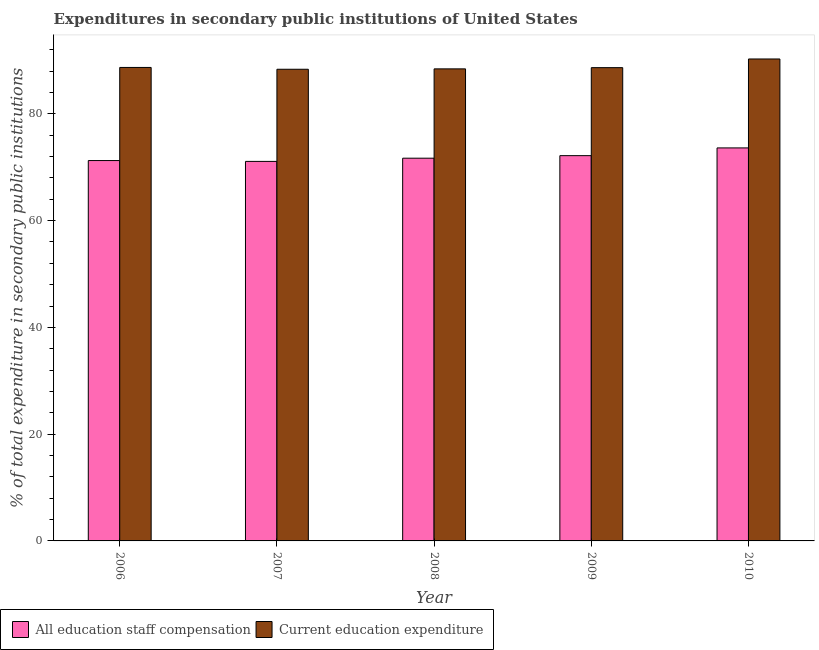How many different coloured bars are there?
Offer a terse response. 2. How many groups of bars are there?
Your answer should be compact. 5. Are the number of bars per tick equal to the number of legend labels?
Keep it short and to the point. Yes. How many bars are there on the 4th tick from the right?
Your answer should be very brief. 2. What is the label of the 4th group of bars from the left?
Give a very brief answer. 2009. What is the expenditure in education in 2009?
Keep it short and to the point. 88.65. Across all years, what is the maximum expenditure in staff compensation?
Make the answer very short. 73.62. Across all years, what is the minimum expenditure in education?
Your answer should be compact. 88.35. What is the total expenditure in staff compensation in the graph?
Offer a terse response. 359.8. What is the difference between the expenditure in education in 2008 and that in 2010?
Your answer should be compact. -1.85. What is the difference between the expenditure in education in 2010 and the expenditure in staff compensation in 2007?
Provide a succinct answer. 1.93. What is the average expenditure in education per year?
Ensure brevity in your answer.  88.88. What is the ratio of the expenditure in staff compensation in 2006 to that in 2010?
Your answer should be compact. 0.97. What is the difference between the highest and the second highest expenditure in staff compensation?
Offer a very short reply. 1.45. What is the difference between the highest and the lowest expenditure in education?
Provide a short and direct response. 1.93. Is the sum of the expenditure in education in 2007 and 2009 greater than the maximum expenditure in staff compensation across all years?
Your answer should be compact. Yes. What does the 2nd bar from the left in 2006 represents?
Offer a terse response. Current education expenditure. What does the 2nd bar from the right in 2007 represents?
Offer a very short reply. All education staff compensation. Does the graph contain any zero values?
Your answer should be very brief. No. Does the graph contain grids?
Your answer should be compact. No. Where does the legend appear in the graph?
Your answer should be very brief. Bottom left. What is the title of the graph?
Your response must be concise. Expenditures in secondary public institutions of United States. What is the label or title of the X-axis?
Your answer should be compact. Year. What is the label or title of the Y-axis?
Provide a succinct answer. % of total expenditure in secondary public institutions. What is the % of total expenditure in secondary public institutions of All education staff compensation in 2006?
Offer a very short reply. 71.25. What is the % of total expenditure in secondary public institutions of Current education expenditure in 2006?
Your answer should be very brief. 88.69. What is the % of total expenditure in secondary public institutions of All education staff compensation in 2007?
Your response must be concise. 71.09. What is the % of total expenditure in secondary public institutions in Current education expenditure in 2007?
Make the answer very short. 88.35. What is the % of total expenditure in secondary public institutions in All education staff compensation in 2008?
Provide a succinct answer. 71.69. What is the % of total expenditure in secondary public institutions in Current education expenditure in 2008?
Your answer should be compact. 88.42. What is the % of total expenditure in secondary public institutions of All education staff compensation in 2009?
Provide a succinct answer. 72.17. What is the % of total expenditure in secondary public institutions of Current education expenditure in 2009?
Your response must be concise. 88.65. What is the % of total expenditure in secondary public institutions in All education staff compensation in 2010?
Provide a short and direct response. 73.62. What is the % of total expenditure in secondary public institutions of Current education expenditure in 2010?
Give a very brief answer. 90.27. Across all years, what is the maximum % of total expenditure in secondary public institutions in All education staff compensation?
Provide a short and direct response. 73.62. Across all years, what is the maximum % of total expenditure in secondary public institutions in Current education expenditure?
Provide a short and direct response. 90.27. Across all years, what is the minimum % of total expenditure in secondary public institutions of All education staff compensation?
Keep it short and to the point. 71.09. Across all years, what is the minimum % of total expenditure in secondary public institutions in Current education expenditure?
Make the answer very short. 88.35. What is the total % of total expenditure in secondary public institutions of All education staff compensation in the graph?
Your answer should be compact. 359.8. What is the total % of total expenditure in secondary public institutions in Current education expenditure in the graph?
Keep it short and to the point. 444.38. What is the difference between the % of total expenditure in secondary public institutions of All education staff compensation in 2006 and that in 2007?
Make the answer very short. 0.16. What is the difference between the % of total expenditure in secondary public institutions in Current education expenditure in 2006 and that in 2007?
Your response must be concise. 0.34. What is the difference between the % of total expenditure in secondary public institutions of All education staff compensation in 2006 and that in 2008?
Ensure brevity in your answer.  -0.44. What is the difference between the % of total expenditure in secondary public institutions of Current education expenditure in 2006 and that in 2008?
Your answer should be very brief. 0.27. What is the difference between the % of total expenditure in secondary public institutions of All education staff compensation in 2006 and that in 2009?
Make the answer very short. -0.92. What is the difference between the % of total expenditure in secondary public institutions of Current education expenditure in 2006 and that in 2009?
Your answer should be very brief. 0.04. What is the difference between the % of total expenditure in secondary public institutions in All education staff compensation in 2006 and that in 2010?
Make the answer very short. -2.37. What is the difference between the % of total expenditure in secondary public institutions of Current education expenditure in 2006 and that in 2010?
Keep it short and to the point. -1.59. What is the difference between the % of total expenditure in secondary public institutions of All education staff compensation in 2007 and that in 2008?
Your answer should be compact. -0.6. What is the difference between the % of total expenditure in secondary public institutions of Current education expenditure in 2007 and that in 2008?
Give a very brief answer. -0.07. What is the difference between the % of total expenditure in secondary public institutions in All education staff compensation in 2007 and that in 2009?
Provide a succinct answer. -1.08. What is the difference between the % of total expenditure in secondary public institutions in Current education expenditure in 2007 and that in 2009?
Provide a succinct answer. -0.3. What is the difference between the % of total expenditure in secondary public institutions of All education staff compensation in 2007 and that in 2010?
Your answer should be very brief. -2.53. What is the difference between the % of total expenditure in secondary public institutions in Current education expenditure in 2007 and that in 2010?
Make the answer very short. -1.93. What is the difference between the % of total expenditure in secondary public institutions in All education staff compensation in 2008 and that in 2009?
Offer a very short reply. -0.48. What is the difference between the % of total expenditure in secondary public institutions in Current education expenditure in 2008 and that in 2009?
Provide a short and direct response. -0.23. What is the difference between the % of total expenditure in secondary public institutions of All education staff compensation in 2008 and that in 2010?
Offer a terse response. -1.93. What is the difference between the % of total expenditure in secondary public institutions of Current education expenditure in 2008 and that in 2010?
Keep it short and to the point. -1.85. What is the difference between the % of total expenditure in secondary public institutions of All education staff compensation in 2009 and that in 2010?
Offer a very short reply. -1.45. What is the difference between the % of total expenditure in secondary public institutions in Current education expenditure in 2009 and that in 2010?
Your answer should be very brief. -1.63. What is the difference between the % of total expenditure in secondary public institutions in All education staff compensation in 2006 and the % of total expenditure in secondary public institutions in Current education expenditure in 2007?
Give a very brief answer. -17.1. What is the difference between the % of total expenditure in secondary public institutions in All education staff compensation in 2006 and the % of total expenditure in secondary public institutions in Current education expenditure in 2008?
Keep it short and to the point. -17.17. What is the difference between the % of total expenditure in secondary public institutions of All education staff compensation in 2006 and the % of total expenditure in secondary public institutions of Current education expenditure in 2009?
Make the answer very short. -17.4. What is the difference between the % of total expenditure in secondary public institutions of All education staff compensation in 2006 and the % of total expenditure in secondary public institutions of Current education expenditure in 2010?
Your answer should be compact. -19.03. What is the difference between the % of total expenditure in secondary public institutions of All education staff compensation in 2007 and the % of total expenditure in secondary public institutions of Current education expenditure in 2008?
Your response must be concise. -17.33. What is the difference between the % of total expenditure in secondary public institutions in All education staff compensation in 2007 and the % of total expenditure in secondary public institutions in Current education expenditure in 2009?
Make the answer very short. -17.56. What is the difference between the % of total expenditure in secondary public institutions of All education staff compensation in 2007 and the % of total expenditure in secondary public institutions of Current education expenditure in 2010?
Offer a very short reply. -19.19. What is the difference between the % of total expenditure in secondary public institutions in All education staff compensation in 2008 and the % of total expenditure in secondary public institutions in Current education expenditure in 2009?
Offer a very short reply. -16.96. What is the difference between the % of total expenditure in secondary public institutions of All education staff compensation in 2008 and the % of total expenditure in secondary public institutions of Current education expenditure in 2010?
Provide a succinct answer. -18.59. What is the difference between the % of total expenditure in secondary public institutions in All education staff compensation in 2009 and the % of total expenditure in secondary public institutions in Current education expenditure in 2010?
Your answer should be compact. -18.11. What is the average % of total expenditure in secondary public institutions of All education staff compensation per year?
Make the answer very short. 71.96. What is the average % of total expenditure in secondary public institutions in Current education expenditure per year?
Provide a short and direct response. 88.88. In the year 2006, what is the difference between the % of total expenditure in secondary public institutions in All education staff compensation and % of total expenditure in secondary public institutions in Current education expenditure?
Your answer should be compact. -17.44. In the year 2007, what is the difference between the % of total expenditure in secondary public institutions in All education staff compensation and % of total expenditure in secondary public institutions in Current education expenditure?
Ensure brevity in your answer.  -17.26. In the year 2008, what is the difference between the % of total expenditure in secondary public institutions in All education staff compensation and % of total expenditure in secondary public institutions in Current education expenditure?
Offer a very short reply. -16.73. In the year 2009, what is the difference between the % of total expenditure in secondary public institutions of All education staff compensation and % of total expenditure in secondary public institutions of Current education expenditure?
Provide a succinct answer. -16.48. In the year 2010, what is the difference between the % of total expenditure in secondary public institutions of All education staff compensation and % of total expenditure in secondary public institutions of Current education expenditure?
Give a very brief answer. -16.66. What is the ratio of the % of total expenditure in secondary public institutions in Current education expenditure in 2006 to that in 2008?
Keep it short and to the point. 1. What is the ratio of the % of total expenditure in secondary public institutions in All education staff compensation in 2006 to that in 2009?
Your answer should be compact. 0.99. What is the ratio of the % of total expenditure in secondary public institutions in All education staff compensation in 2006 to that in 2010?
Make the answer very short. 0.97. What is the ratio of the % of total expenditure in secondary public institutions in Current education expenditure in 2006 to that in 2010?
Offer a terse response. 0.98. What is the ratio of the % of total expenditure in secondary public institutions of All education staff compensation in 2007 to that in 2009?
Provide a short and direct response. 0.99. What is the ratio of the % of total expenditure in secondary public institutions of All education staff compensation in 2007 to that in 2010?
Your answer should be very brief. 0.97. What is the ratio of the % of total expenditure in secondary public institutions of Current education expenditure in 2007 to that in 2010?
Offer a very short reply. 0.98. What is the ratio of the % of total expenditure in secondary public institutions of All education staff compensation in 2008 to that in 2009?
Offer a very short reply. 0.99. What is the ratio of the % of total expenditure in secondary public institutions of Current education expenditure in 2008 to that in 2009?
Keep it short and to the point. 1. What is the ratio of the % of total expenditure in secondary public institutions in All education staff compensation in 2008 to that in 2010?
Your answer should be compact. 0.97. What is the ratio of the % of total expenditure in secondary public institutions in Current education expenditure in 2008 to that in 2010?
Ensure brevity in your answer.  0.98. What is the ratio of the % of total expenditure in secondary public institutions in All education staff compensation in 2009 to that in 2010?
Provide a succinct answer. 0.98. What is the ratio of the % of total expenditure in secondary public institutions in Current education expenditure in 2009 to that in 2010?
Give a very brief answer. 0.98. What is the difference between the highest and the second highest % of total expenditure in secondary public institutions in All education staff compensation?
Offer a very short reply. 1.45. What is the difference between the highest and the second highest % of total expenditure in secondary public institutions in Current education expenditure?
Offer a very short reply. 1.59. What is the difference between the highest and the lowest % of total expenditure in secondary public institutions in All education staff compensation?
Give a very brief answer. 2.53. What is the difference between the highest and the lowest % of total expenditure in secondary public institutions in Current education expenditure?
Make the answer very short. 1.93. 